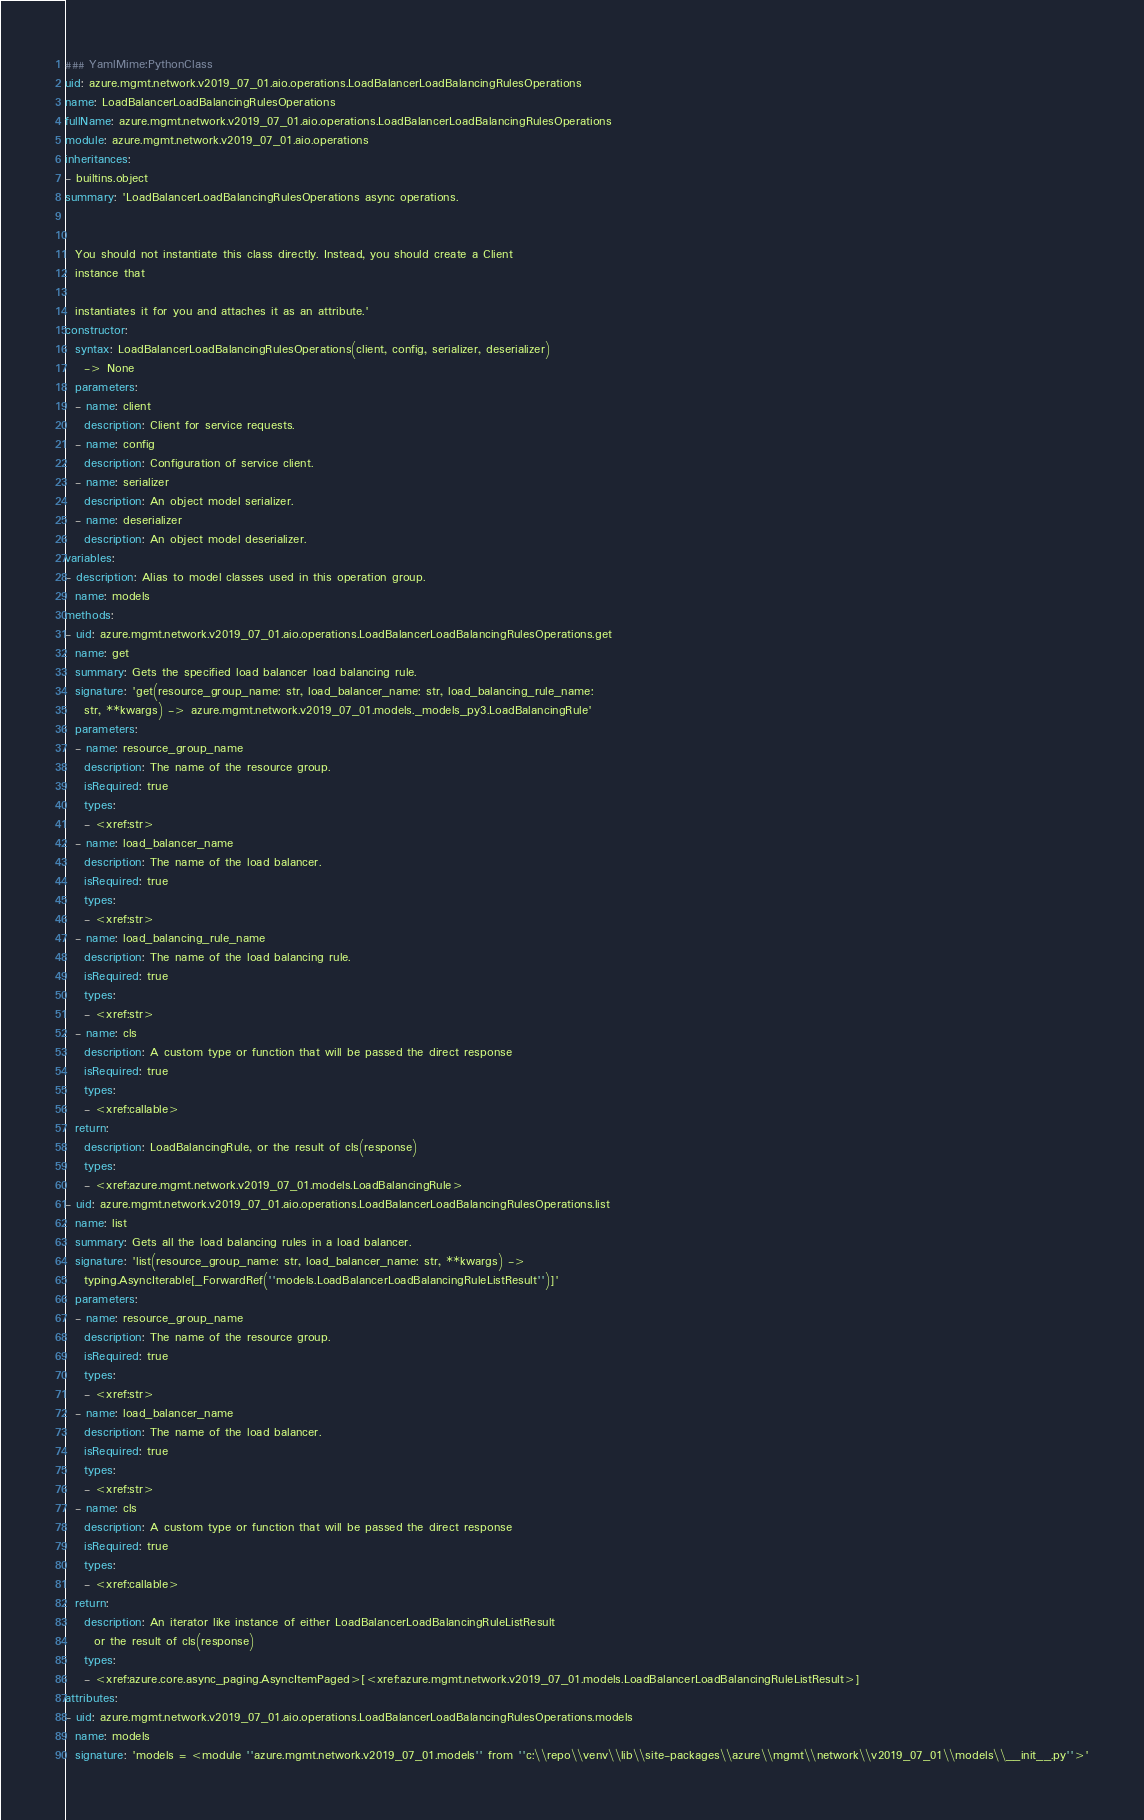Convert code to text. <code><loc_0><loc_0><loc_500><loc_500><_YAML_>### YamlMime:PythonClass
uid: azure.mgmt.network.v2019_07_01.aio.operations.LoadBalancerLoadBalancingRulesOperations
name: LoadBalancerLoadBalancingRulesOperations
fullName: azure.mgmt.network.v2019_07_01.aio.operations.LoadBalancerLoadBalancingRulesOperations
module: azure.mgmt.network.v2019_07_01.aio.operations
inheritances:
- builtins.object
summary: 'LoadBalancerLoadBalancingRulesOperations async operations.


  You should not instantiate this class directly. Instead, you should create a Client
  instance that

  instantiates it for you and attaches it as an attribute.'
constructor:
  syntax: LoadBalancerLoadBalancingRulesOperations(client, config, serializer, deserializer)
    -> None
  parameters:
  - name: client
    description: Client for service requests.
  - name: config
    description: Configuration of service client.
  - name: serializer
    description: An object model serializer.
  - name: deserializer
    description: An object model deserializer.
variables:
- description: Alias to model classes used in this operation group.
  name: models
methods:
- uid: azure.mgmt.network.v2019_07_01.aio.operations.LoadBalancerLoadBalancingRulesOperations.get
  name: get
  summary: Gets the specified load balancer load balancing rule.
  signature: 'get(resource_group_name: str, load_balancer_name: str, load_balancing_rule_name:
    str, **kwargs) -> azure.mgmt.network.v2019_07_01.models._models_py3.LoadBalancingRule'
  parameters:
  - name: resource_group_name
    description: The name of the resource group.
    isRequired: true
    types:
    - <xref:str>
  - name: load_balancer_name
    description: The name of the load balancer.
    isRequired: true
    types:
    - <xref:str>
  - name: load_balancing_rule_name
    description: The name of the load balancing rule.
    isRequired: true
    types:
    - <xref:str>
  - name: cls
    description: A custom type or function that will be passed the direct response
    isRequired: true
    types:
    - <xref:callable>
  return:
    description: LoadBalancingRule, or the result of cls(response)
    types:
    - <xref:azure.mgmt.network.v2019_07_01.models.LoadBalancingRule>
- uid: azure.mgmt.network.v2019_07_01.aio.operations.LoadBalancerLoadBalancingRulesOperations.list
  name: list
  summary: Gets all the load balancing rules in a load balancer.
  signature: 'list(resource_group_name: str, load_balancer_name: str, **kwargs) ->
    typing.AsyncIterable[_ForwardRef(''models.LoadBalancerLoadBalancingRuleListResult'')]'
  parameters:
  - name: resource_group_name
    description: The name of the resource group.
    isRequired: true
    types:
    - <xref:str>
  - name: load_balancer_name
    description: The name of the load balancer.
    isRequired: true
    types:
    - <xref:str>
  - name: cls
    description: A custom type or function that will be passed the direct response
    isRequired: true
    types:
    - <xref:callable>
  return:
    description: An iterator like instance of either LoadBalancerLoadBalancingRuleListResult
      or the result of cls(response)
    types:
    - <xref:azure.core.async_paging.AsyncItemPaged>[<xref:azure.mgmt.network.v2019_07_01.models.LoadBalancerLoadBalancingRuleListResult>]
attributes:
- uid: azure.mgmt.network.v2019_07_01.aio.operations.LoadBalancerLoadBalancingRulesOperations.models
  name: models
  signature: 'models = <module ''azure.mgmt.network.v2019_07_01.models'' from ''c:\\repo\\venv\\lib\\site-packages\\azure\\mgmt\\network\\v2019_07_01\\models\\__init__.py''>'
</code> 